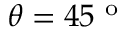<formula> <loc_0><loc_0><loc_500><loc_500>\theta = 4 5 ^ { o }</formula> 